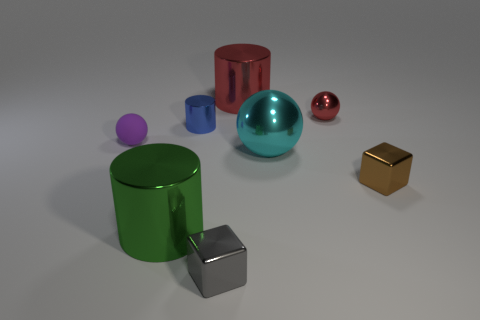Add 1 brown things. How many objects exist? 9 Subtract all blocks. How many objects are left? 6 Add 5 small red balls. How many small red balls exist? 6 Subtract 0 yellow balls. How many objects are left? 8 Subtract all red blocks. Subtract all large metal spheres. How many objects are left? 7 Add 7 small shiny cylinders. How many small shiny cylinders are left? 8 